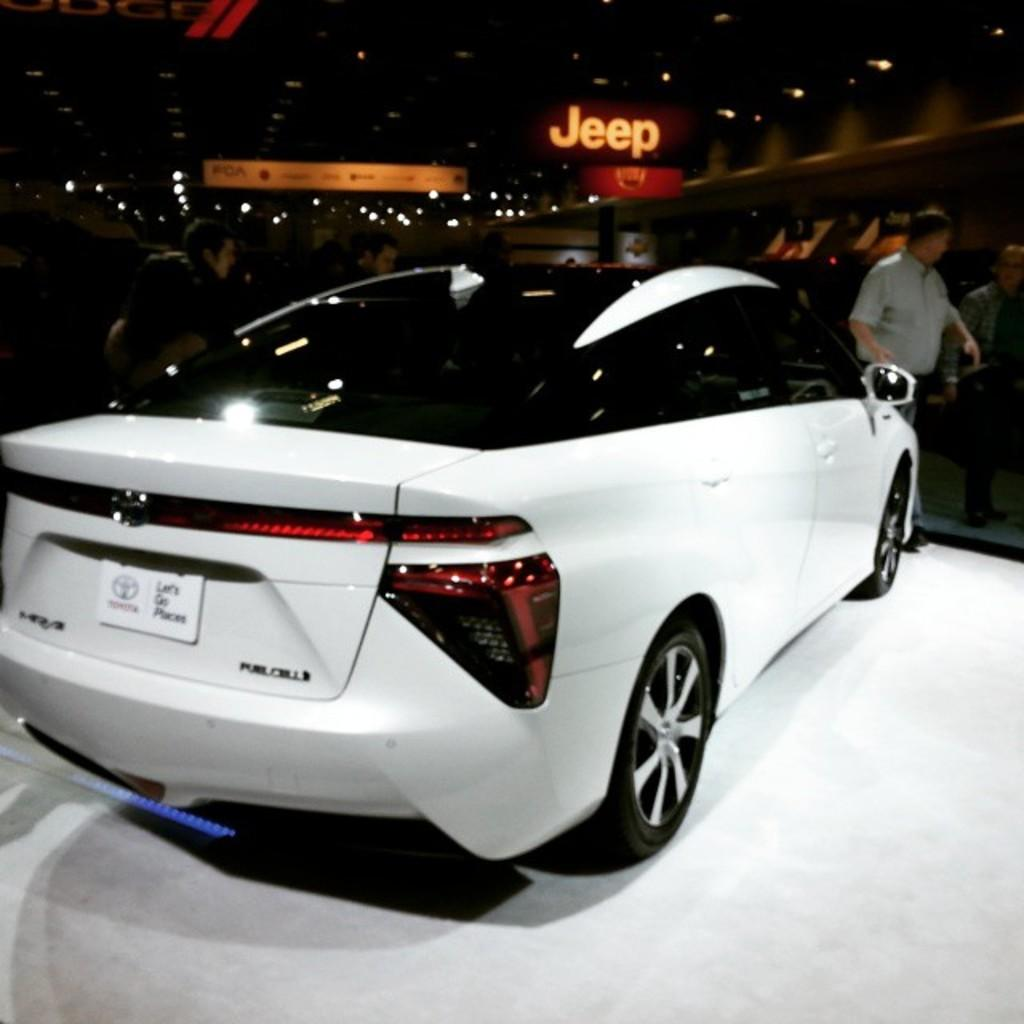What is the main subject of the image? There is a car in the image. Can you describe the car's appearance? The car is white in color. What can be seen in the background of the image? There are persons, lights, and some text written on a board in the background of the image. What type of powder is being used to clean the dock in the image? There is no dock or powder present in the image. What is the car's need for the text written on the board in the image? The car does not have a need for the text written on the board, as it is a separate element in the background. 